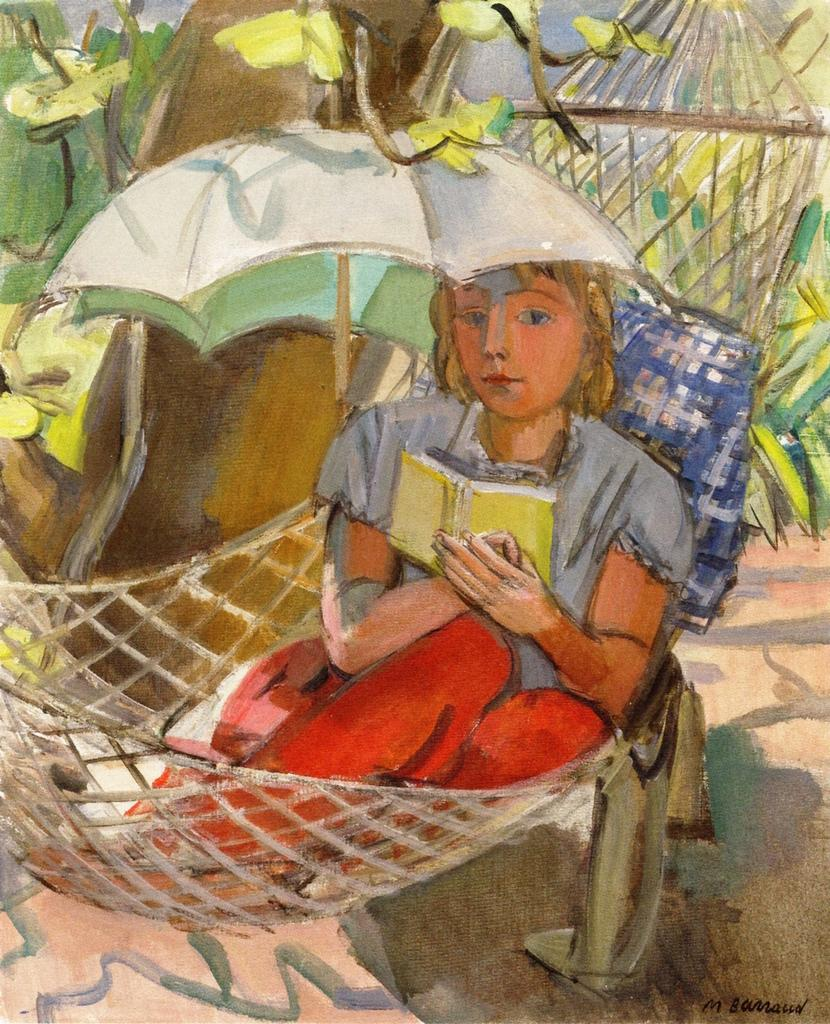What is depicted on the poster in the image? There is a poster with a painting in the image. What is the person in the image sitting on? There is a person sitting on an object in the image. What type of soft furnishing can be seen in the image? There is a pillow in the image. What type of accessory is present in the image? There is an umbrella in the image. What type of fabric is visible in the image? There is cloth in the image. What type of natural elements are present in the image? There are flowers and a tree in the image. What type of stew is being prepared in the image? There is no stew being prepared in the image; it features a poster with a painting, a person sitting on an object, a pillow, an umbrella, cloth, flowers, and a tree. How many beds are visible in the image? There are no beds visible in the image. 